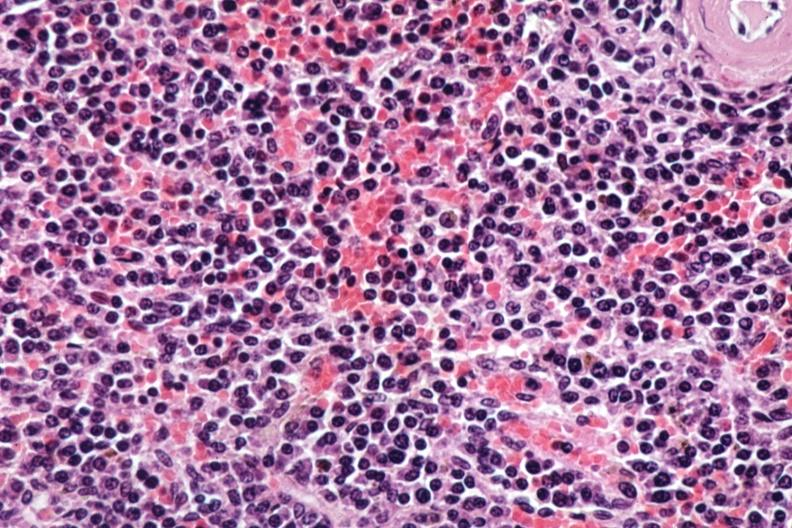what is present?
Answer the question using a single word or phrase. Multiple myeloma 